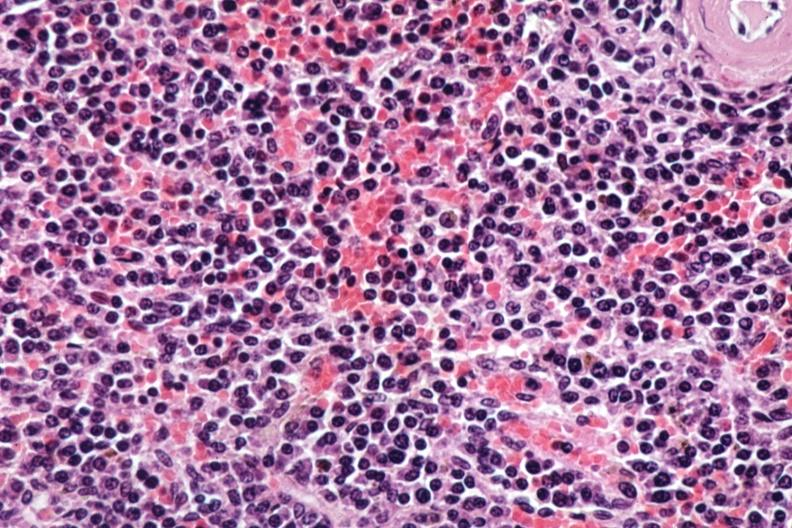what is present?
Answer the question using a single word or phrase. Multiple myeloma 